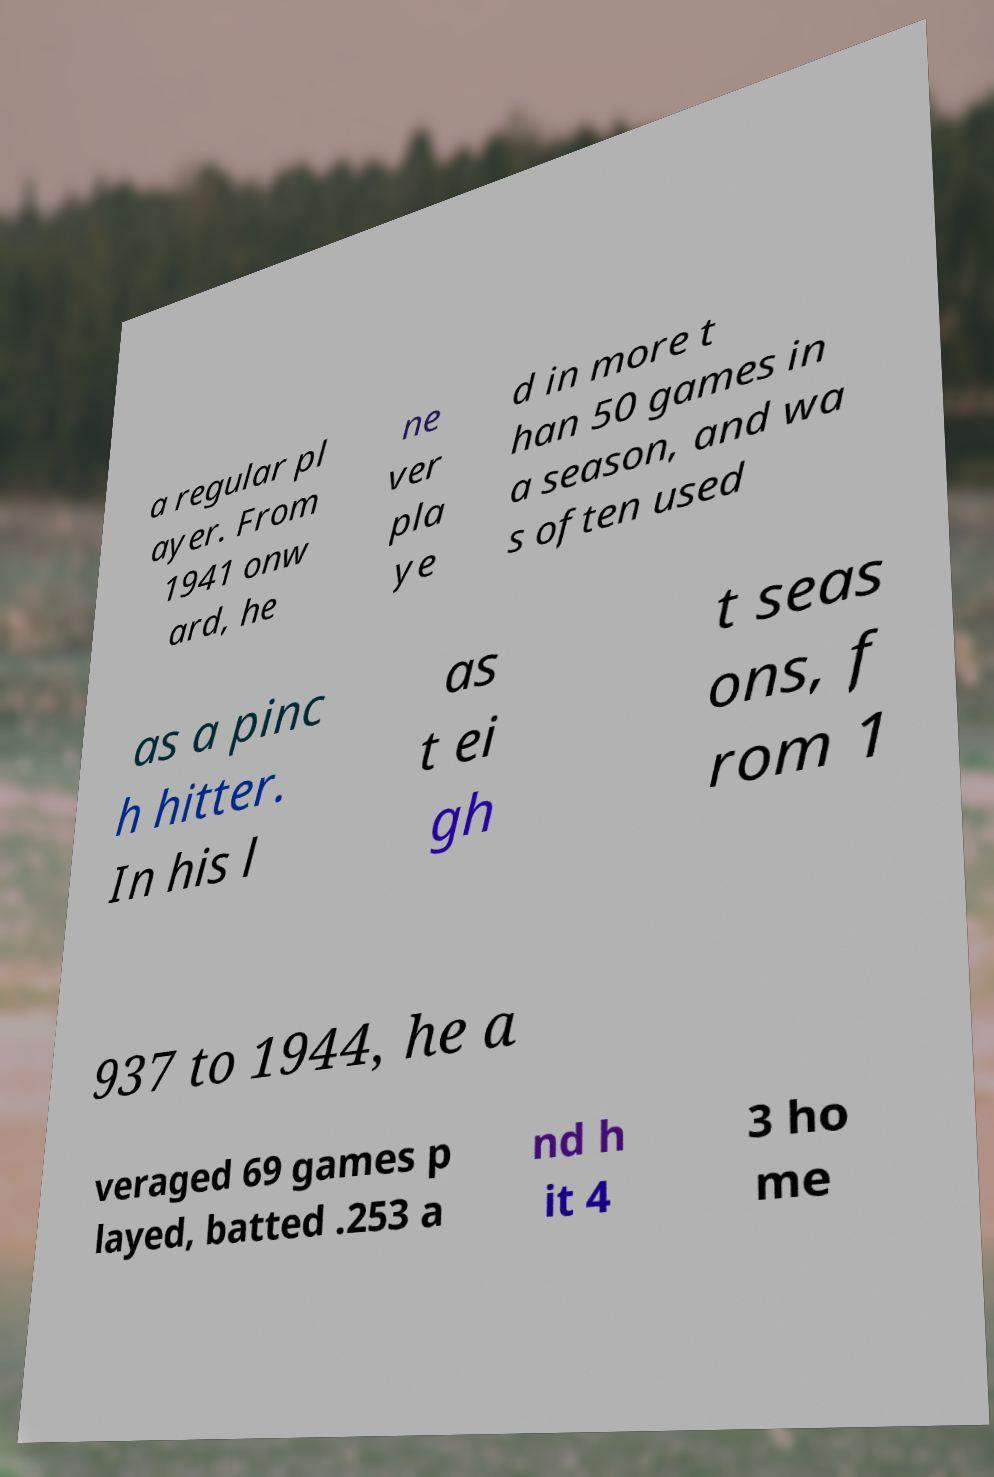For documentation purposes, I need the text within this image transcribed. Could you provide that? a regular pl ayer. From 1941 onw ard, he ne ver pla ye d in more t han 50 games in a season, and wa s often used as a pinc h hitter. In his l as t ei gh t seas ons, f rom 1 937 to 1944, he a veraged 69 games p layed, batted .253 a nd h it 4 3 ho me 